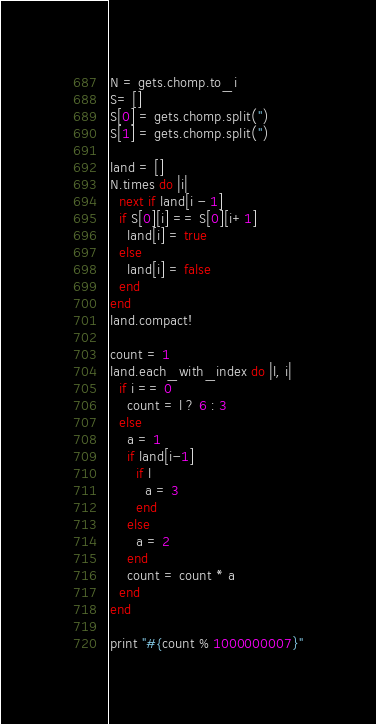Convert code to text. <code><loc_0><loc_0><loc_500><loc_500><_Ruby_>N = gets.chomp.to_i
S= []
S[0] = gets.chomp.split('')
S[1] = gets.chomp.split('')

land = []
N.times do |i|
  next if land[i - 1]
  if S[0][i] == S[0][i+1]
    land[i] = true
  else
    land[i] = false
  end
end
land.compact!

count = 1
land.each_with_index do |l, i|
  if i == 0
    count = l ? 6 : 3
  else
    a = 1
    if land[i-1]
      if l
        a = 3
      end
    else
      a = 2
    end
    count = count * a
  end
end

print "#{count % 1000000007}"</code> 